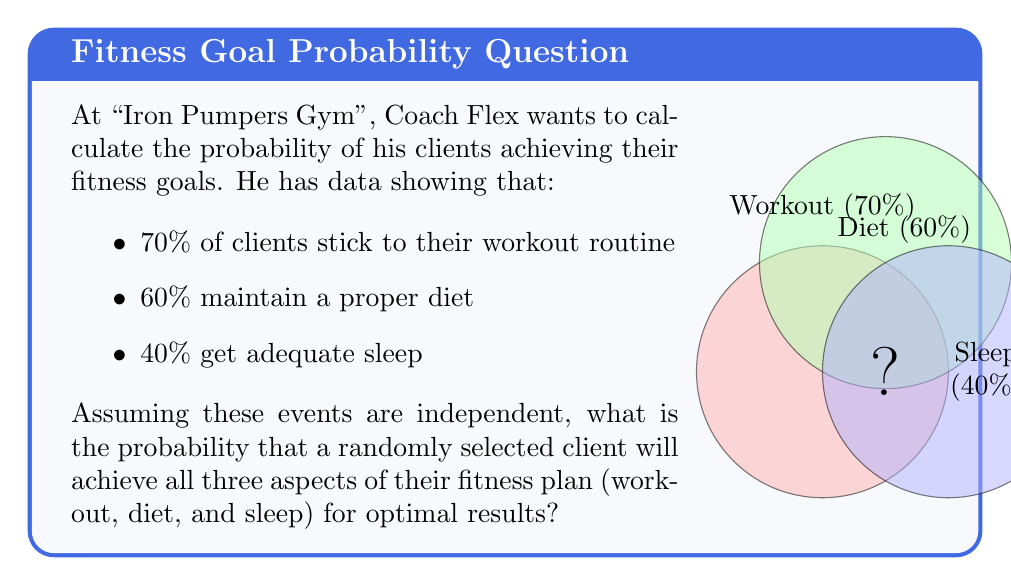Teach me how to tackle this problem. Let's approach this step-by-step using basic probability theory:

1) We're dealing with three independent events:
   A: Sticking to workout routine (70% or 0.7)
   B: Maintaining proper diet (60% or 0.6)
   C: Getting adequate sleep (40% or 0.4)

2) We want to find the probability of all these events occurring together.

3) For independent events, the probability of all events occurring is the product of their individual probabilities.

4) We can express this mathematically as:

   $$P(A \cap B \cap C) = P(A) \times P(B) \times P(C)$$

5) Substituting the given probabilities:

   $$P(A \cap B \cap C) = 0.7 \times 0.6 \times 0.4$$

6) Calculating:

   $$P(A \cap B \cap C) = 0.168$$

7) Converting to a percentage:

   $$0.168 \times 100\% = 16.8\%$$

Therefore, the probability that a randomly selected client will achieve all three aspects of their fitness plan is 16.8%.
Answer: 16.8% 